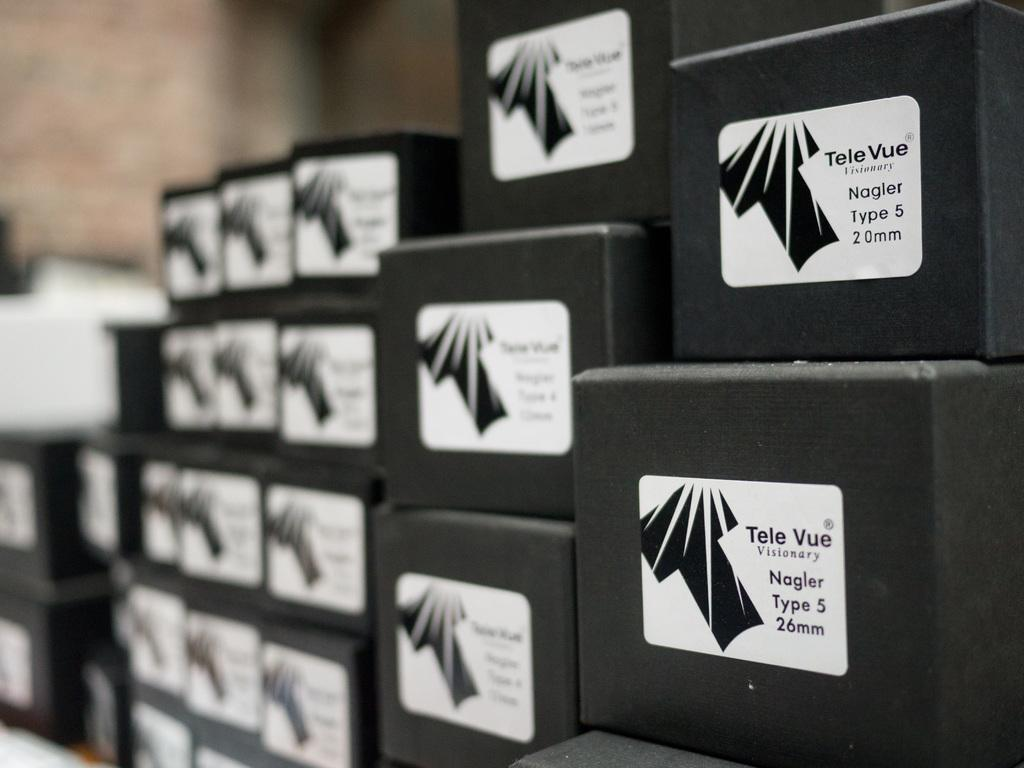<image>
Summarize the visual content of the image. Black boxes with a label from Tele Vue are stacked on top of each other. 